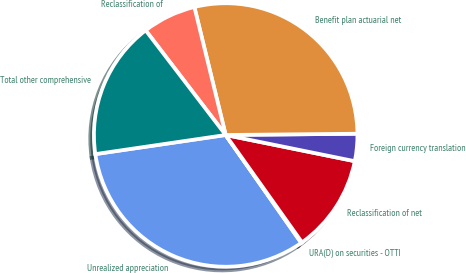<chart> <loc_0><loc_0><loc_500><loc_500><pie_chart><fcel>Unrealized appreciation<fcel>URA(D) on securities - OTTI<fcel>Reclassification of net<fcel>Foreign currency translation<fcel>Benefit plan actuarial net<fcel>Reclassification of<fcel>Total other comprehensive<nl><fcel>32.41%<fcel>0.11%<fcel>11.98%<fcel>3.34%<fcel>28.67%<fcel>6.57%<fcel>16.93%<nl></chart> 